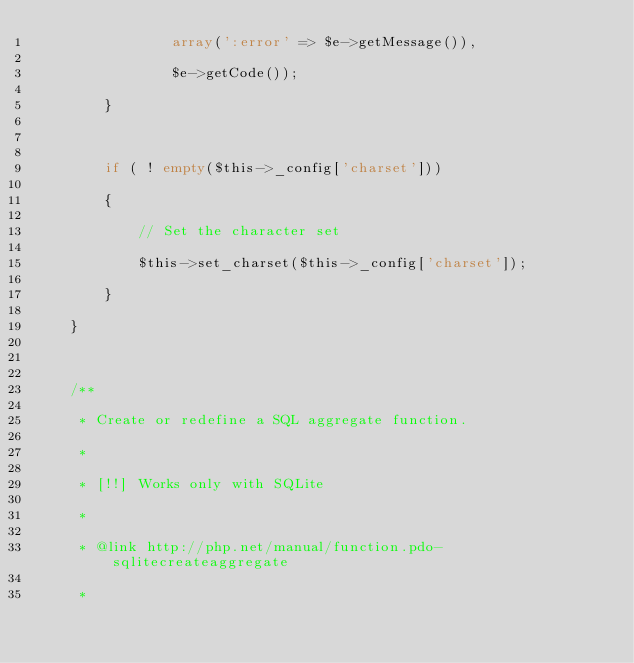Convert code to text. <code><loc_0><loc_0><loc_500><loc_500><_PHP_>				array(':error' => $e->getMessage()),
				$e->getCode());
		}

		if ( ! empty($this->_config['charset']))
		{
			// Set the character set
			$this->set_charset($this->_config['charset']);
		}
	}

	/**
	 * Create or redefine a SQL aggregate function.
	 *
	 * [!!] Works only with SQLite
	 *
	 * @link http://php.net/manual/function.pdo-sqlitecreateaggregate
	 *</code> 